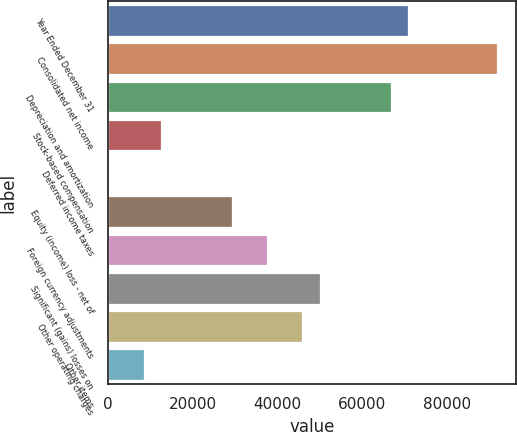Convert chart to OTSL. <chart><loc_0><loc_0><loc_500><loc_500><bar_chart><fcel>Year Ended December 31<fcel>Consolidated net income<fcel>Depreciation and amortization<fcel>Stock-based compensation<fcel>Deferred income taxes<fcel>Equity (income) loss - net of<fcel>Foreign currency adjustments<fcel>Significant (gains) losses on<fcel>Other operating charges<fcel>Other items<nl><fcel>70817.8<fcel>91634.8<fcel>66654.4<fcel>12530.2<fcel>40<fcel>29183.8<fcel>37510.6<fcel>50000.8<fcel>45837.4<fcel>8366.8<nl></chart> 